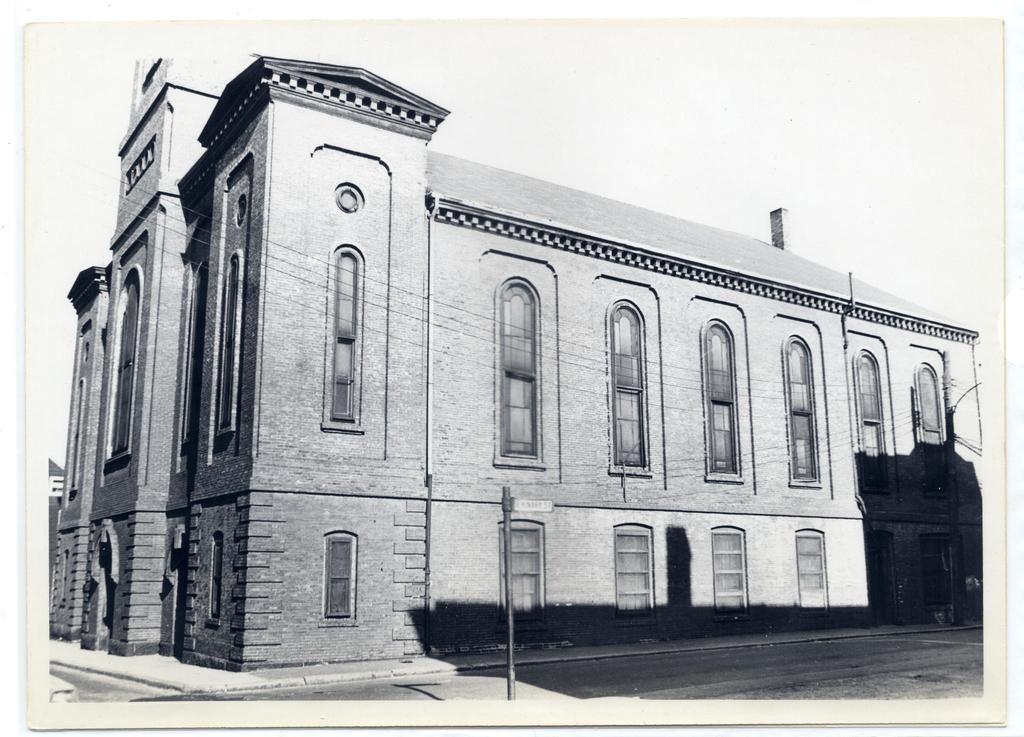What type of structure is visible in the image? There is a building in the image. What else can be seen in the image besides the building? There are poles and wires visible in the image. Can you describe the shadow in the image? There is a shadow in the image, but its exact location or source cannot be determined from the provided facts. What is the color scheme of the image? The image is black and white in color. How many tomatoes are hanging from the bit in the image? There are no tomatoes or bits present in the image. Can you describe the fang of the creature in the image? There is no creature or fang present in the image. 